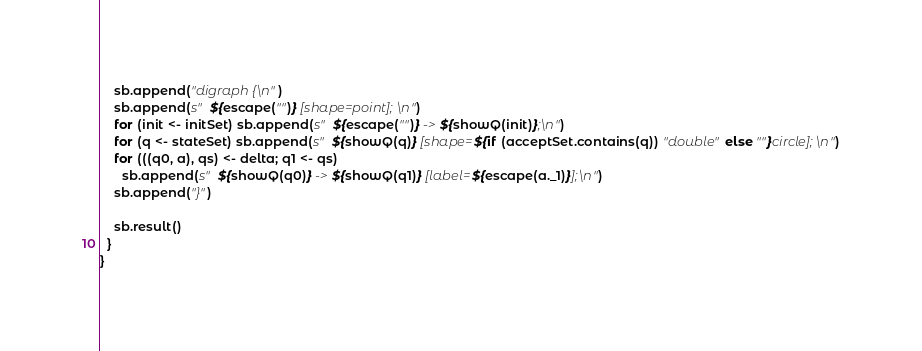Convert code to text. <code><loc_0><loc_0><loc_500><loc_500><_Scala_>
    sb.append("digraph {\n")
    sb.append(s"  ${escape("")} [shape=point];\n")
    for (init <- initSet) sb.append(s"  ${escape("")} -> ${showQ(init)};\n")
    for (q <- stateSet) sb.append(s"  ${showQ(q)} [shape=${if (acceptSet.contains(q)) "double" else ""}circle];\n")
    for (((q0, a), qs) <- delta; q1 <- qs)
      sb.append(s"  ${showQ(q0)} -> ${showQ(q1)} [label=${escape(a._1)}];\n")
    sb.append("}")

    sb.result()
  }
}
</code> 